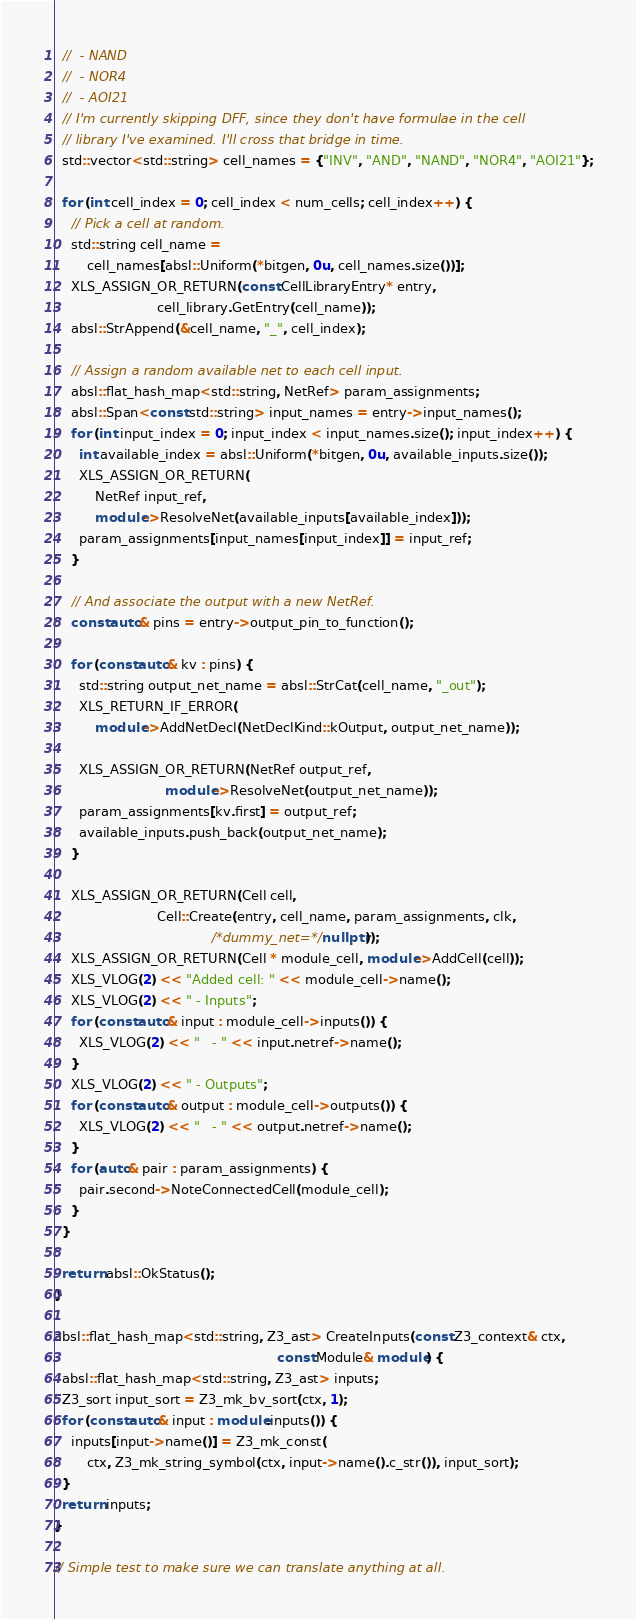Convert code to text. <code><loc_0><loc_0><loc_500><loc_500><_C++_>  //  - NAND
  //  - NOR4
  //  - AOI21
  // I'm currently skipping DFF, since they don't have formulae in the cell
  // library I've examined. I'll cross that bridge in time.
  std::vector<std::string> cell_names = {"INV", "AND", "NAND", "NOR4", "AOI21"};

  for (int cell_index = 0; cell_index < num_cells; cell_index++) {
    // Pick a cell at random.
    std::string cell_name =
        cell_names[absl::Uniform(*bitgen, 0u, cell_names.size())];
    XLS_ASSIGN_OR_RETURN(const CellLibraryEntry* entry,
                         cell_library.GetEntry(cell_name));
    absl::StrAppend(&cell_name, "_", cell_index);

    // Assign a random available net to each cell input.
    absl::flat_hash_map<std::string, NetRef> param_assignments;
    absl::Span<const std::string> input_names = entry->input_names();
    for (int input_index = 0; input_index < input_names.size(); input_index++) {
      int available_index = absl::Uniform(*bitgen, 0u, available_inputs.size());
      XLS_ASSIGN_OR_RETURN(
          NetRef input_ref,
          module->ResolveNet(available_inputs[available_index]));
      param_assignments[input_names[input_index]] = input_ref;
    }

    // And associate the output with a new NetRef.
    const auto& pins = entry->output_pin_to_function();

    for (const auto& kv : pins) {
      std::string output_net_name = absl::StrCat(cell_name, "_out");
      XLS_RETURN_IF_ERROR(
          module->AddNetDecl(NetDeclKind::kOutput, output_net_name));

      XLS_ASSIGN_OR_RETURN(NetRef output_ref,
                           module->ResolveNet(output_net_name));
      param_assignments[kv.first] = output_ref;
      available_inputs.push_back(output_net_name);
    }

    XLS_ASSIGN_OR_RETURN(Cell cell,
                         Cell::Create(entry, cell_name, param_assignments, clk,
                                      /*dummy_net=*/nullptr));
    XLS_ASSIGN_OR_RETURN(Cell * module_cell, module->AddCell(cell));
    XLS_VLOG(2) << "Added cell: " << module_cell->name();
    XLS_VLOG(2) << " - Inputs";
    for (const auto& input : module_cell->inputs()) {
      XLS_VLOG(2) << "   - " << input.netref->name();
    }
    XLS_VLOG(2) << " - Outputs";
    for (const auto& output : module_cell->outputs()) {
      XLS_VLOG(2) << "   - " << output.netref->name();
    }
    for (auto& pair : param_assignments) {
      pair.second->NoteConnectedCell(module_cell);
    }
  }

  return absl::OkStatus();
}

absl::flat_hash_map<std::string, Z3_ast> CreateInputs(const Z3_context& ctx,
                                                      const Module& module) {
  absl::flat_hash_map<std::string, Z3_ast> inputs;
  Z3_sort input_sort = Z3_mk_bv_sort(ctx, 1);
  for (const auto& input : module.inputs()) {
    inputs[input->name()] = Z3_mk_const(
        ctx, Z3_mk_string_symbol(ctx, input->name().c_str()), input_sort);
  }
  return inputs;
}

// Simple test to make sure we can translate anything at all.</code> 